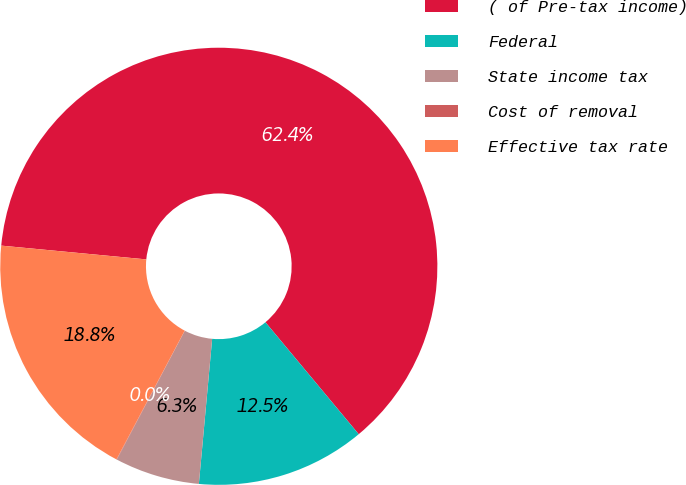Convert chart. <chart><loc_0><loc_0><loc_500><loc_500><pie_chart><fcel>( of Pre-tax income)<fcel>Federal<fcel>State income tax<fcel>Cost of removal<fcel>Effective tax rate<nl><fcel>62.43%<fcel>12.51%<fcel>6.27%<fcel>0.03%<fcel>18.75%<nl></chart> 